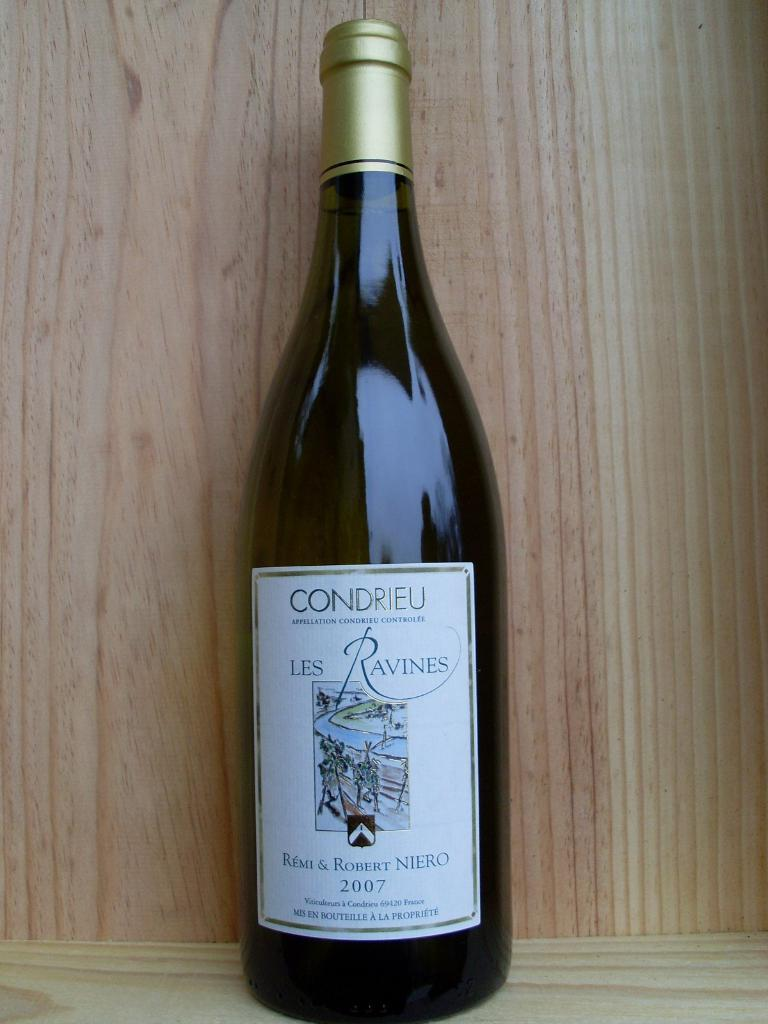<image>
Render a clear and concise summary of the photo. A bottle has the year 2007 on the label and the brand is Les Ravines. 